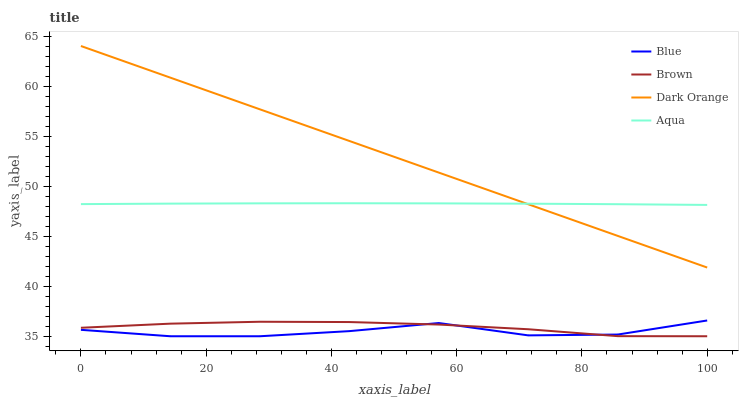Does Blue have the minimum area under the curve?
Answer yes or no. Yes. Does Dark Orange have the maximum area under the curve?
Answer yes or no. Yes. Does Brown have the minimum area under the curve?
Answer yes or no. No. Does Brown have the maximum area under the curve?
Answer yes or no. No. Is Dark Orange the smoothest?
Answer yes or no. Yes. Is Blue the roughest?
Answer yes or no. Yes. Is Brown the smoothest?
Answer yes or no. No. Is Brown the roughest?
Answer yes or no. No. Does Aqua have the lowest value?
Answer yes or no. No. Does Dark Orange have the highest value?
Answer yes or no. Yes. Does Aqua have the highest value?
Answer yes or no. No. Is Brown less than Aqua?
Answer yes or no. Yes. Is Dark Orange greater than Brown?
Answer yes or no. Yes. Does Brown intersect Blue?
Answer yes or no. Yes. Is Brown less than Blue?
Answer yes or no. No. Is Brown greater than Blue?
Answer yes or no. No. Does Brown intersect Aqua?
Answer yes or no. No. 